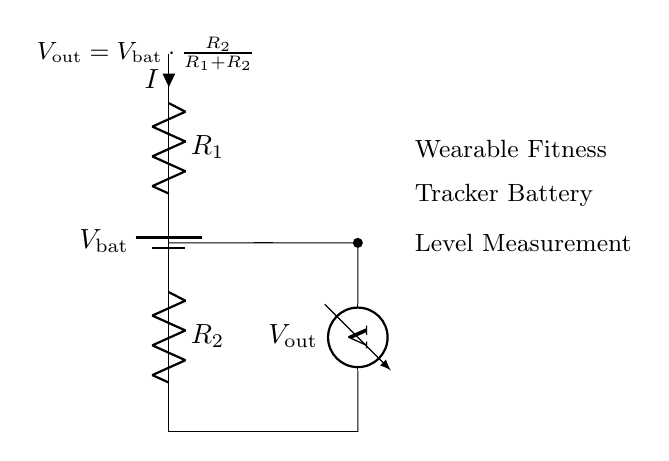What type of circuit is depicted? The circuit shown is a voltage divider, which consists of two resistors configured to divide the input voltage into a smaller output voltage based on the resistor values.
Answer: voltage divider What is the input voltage to the circuit? The input voltage, indicated by the battery symbol, is labeled as V bat, representing the voltage provided by the wearable tracker battery.
Answer: V bat What are the two resistors labeled as? The two resistors are labeled as R 1 and R 2, which determine the division of the input voltage across them.
Answer: R 1 and R 2 What is the output voltage formula given in the circuit? The output voltage formula provided in the circuit is V out equals V bat multiplied by R 2 divided by the sum of R 1 and R 2, showing how the output voltage depends on the resistors and the input voltage.
Answer: V out = V bat ⋅ R 2 / (R 1 + R 2) If R 1 is twice the value of R 2, what would be the output voltage ratio? Since R 1 is twice the value of R 2, the formula can be simplified: if R 1 equals 2R 2, then V out equals V bat multiplied by R 2 divided by 3R 2, resulting in V out equals one-third of V bat.
Answer: one-third of V bat What role does the voltmeter play in this circuit? The voltmeter is used to measure the output voltage V out across R 2, allowing for the assessment of the battery level based on the voltage divider principle.
Answer: measure output voltage How does changing R 2 affect V out? Increasing R 2 will increase V out because the larger resistor allows a greater portion of V bat to be dropped across it, while decreasing R 2 will lower V out as more voltage drops across R 1.
Answer: increases V out 